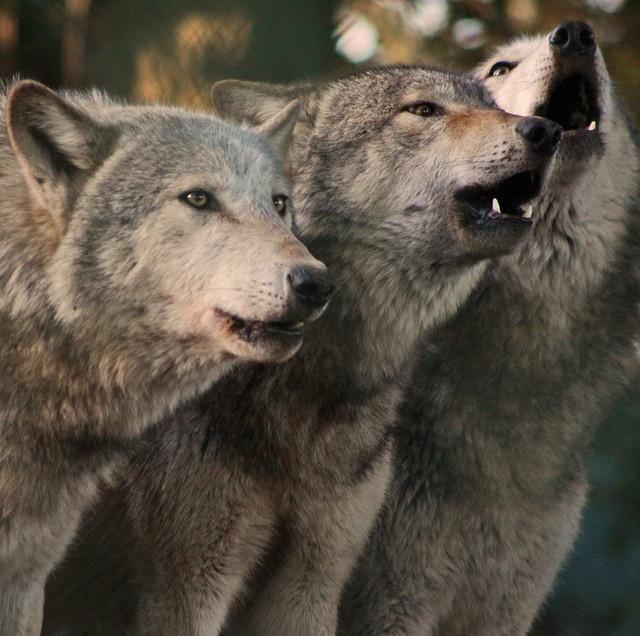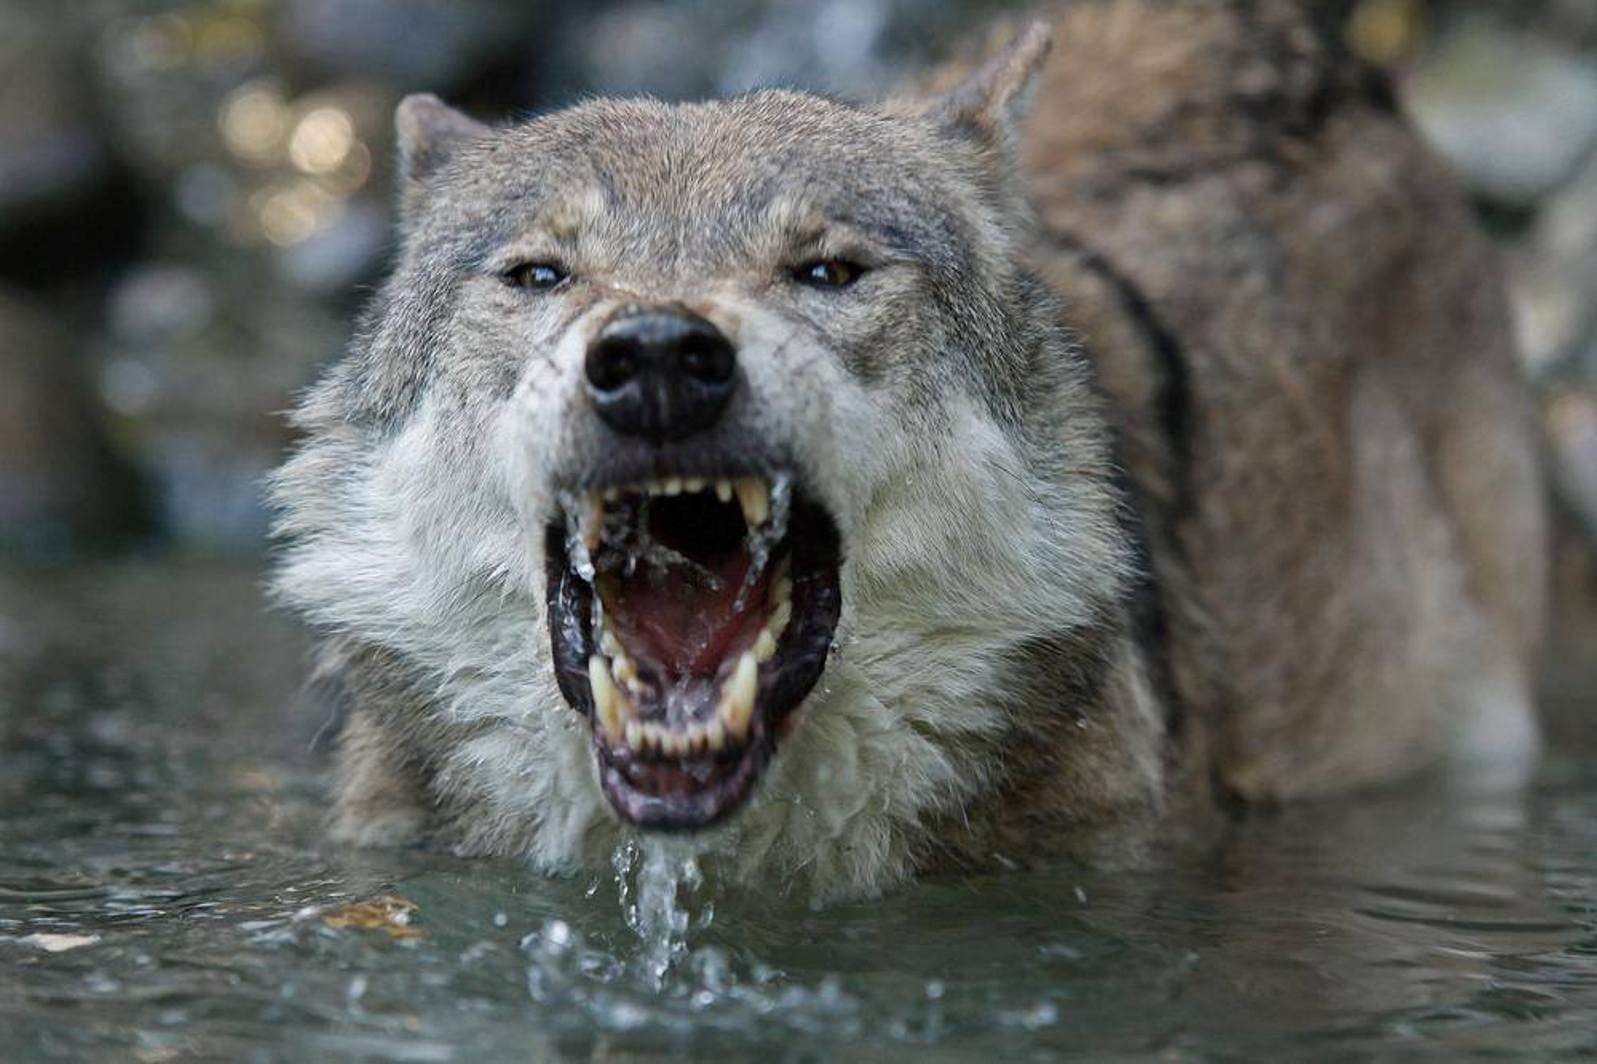The first image is the image on the left, the second image is the image on the right. For the images shown, is this caption "There is at least two wolves in the left image." true? Answer yes or no. Yes. The first image is the image on the left, the second image is the image on the right. Evaluate the accuracy of this statement regarding the images: "A camera-facing wolf has fangs bared in a fierce expression.". Is it true? Answer yes or no. Yes. 